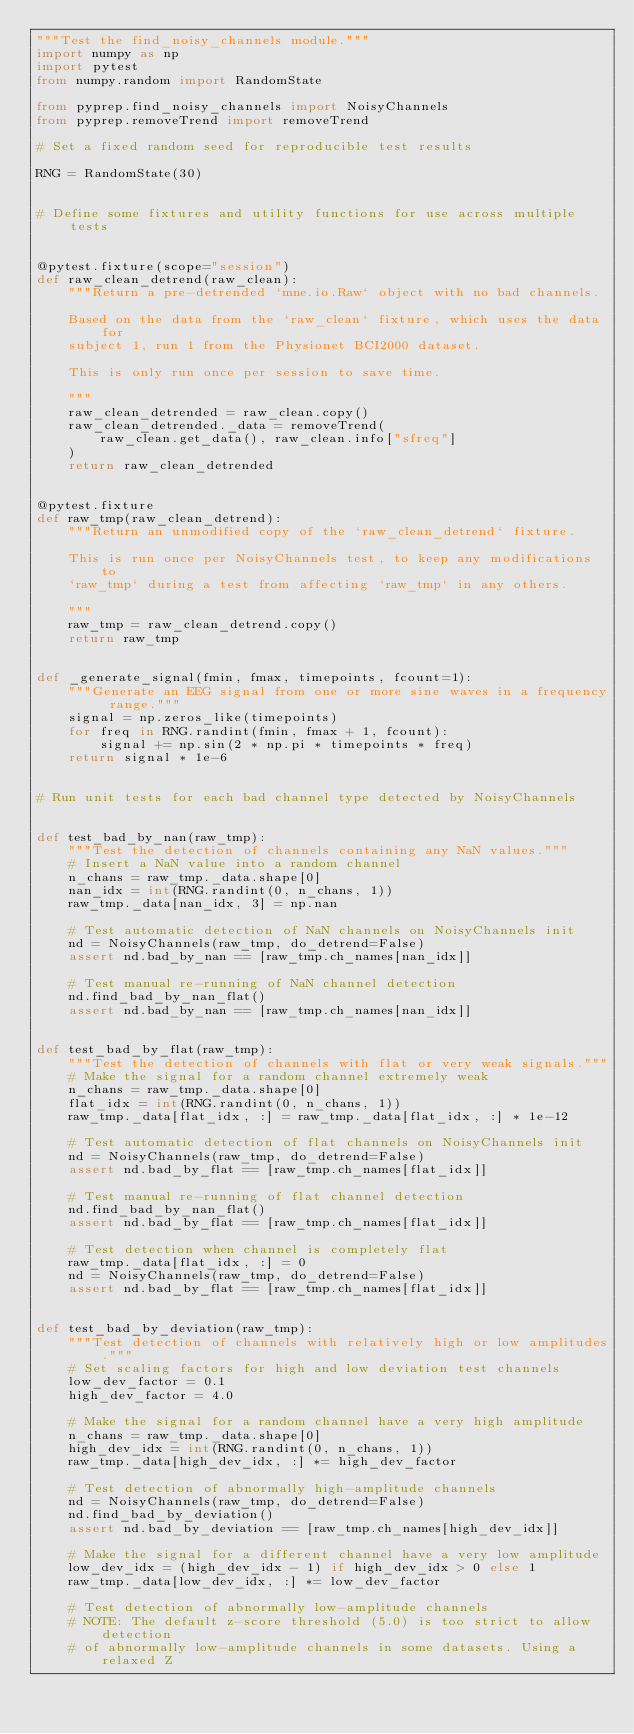Convert code to text. <code><loc_0><loc_0><loc_500><loc_500><_Python_>"""Test the find_noisy_channels module."""
import numpy as np
import pytest
from numpy.random import RandomState

from pyprep.find_noisy_channels import NoisyChannels
from pyprep.removeTrend import removeTrend

# Set a fixed random seed for reproducible test results

RNG = RandomState(30)


# Define some fixtures and utility functions for use across multiple tests


@pytest.fixture(scope="session")
def raw_clean_detrend(raw_clean):
    """Return a pre-detrended `mne.io.Raw` object with no bad channels.

    Based on the data from the `raw_clean` fixture, which uses the data for
    subject 1, run 1 from the Physionet BCI2000 dataset.

    This is only run once per session to save time.

    """
    raw_clean_detrended = raw_clean.copy()
    raw_clean_detrended._data = removeTrend(
        raw_clean.get_data(), raw_clean.info["sfreq"]
    )
    return raw_clean_detrended


@pytest.fixture
def raw_tmp(raw_clean_detrend):
    """Return an unmodified copy of the `raw_clean_detrend` fixture.

    This is run once per NoisyChannels test, to keep any modifications to
    `raw_tmp` during a test from affecting `raw_tmp` in any others.

    """
    raw_tmp = raw_clean_detrend.copy()
    return raw_tmp


def _generate_signal(fmin, fmax, timepoints, fcount=1):
    """Generate an EEG signal from one or more sine waves in a frequency range."""
    signal = np.zeros_like(timepoints)
    for freq in RNG.randint(fmin, fmax + 1, fcount):
        signal += np.sin(2 * np.pi * timepoints * freq)
    return signal * 1e-6


# Run unit tests for each bad channel type detected by NoisyChannels


def test_bad_by_nan(raw_tmp):
    """Test the detection of channels containing any NaN values."""
    # Insert a NaN value into a random channel
    n_chans = raw_tmp._data.shape[0]
    nan_idx = int(RNG.randint(0, n_chans, 1))
    raw_tmp._data[nan_idx, 3] = np.nan

    # Test automatic detection of NaN channels on NoisyChannels init
    nd = NoisyChannels(raw_tmp, do_detrend=False)
    assert nd.bad_by_nan == [raw_tmp.ch_names[nan_idx]]

    # Test manual re-running of NaN channel detection
    nd.find_bad_by_nan_flat()
    assert nd.bad_by_nan == [raw_tmp.ch_names[nan_idx]]


def test_bad_by_flat(raw_tmp):
    """Test the detection of channels with flat or very weak signals."""
    # Make the signal for a random channel extremely weak
    n_chans = raw_tmp._data.shape[0]
    flat_idx = int(RNG.randint(0, n_chans, 1))
    raw_tmp._data[flat_idx, :] = raw_tmp._data[flat_idx, :] * 1e-12

    # Test automatic detection of flat channels on NoisyChannels init
    nd = NoisyChannels(raw_tmp, do_detrend=False)
    assert nd.bad_by_flat == [raw_tmp.ch_names[flat_idx]]

    # Test manual re-running of flat channel detection
    nd.find_bad_by_nan_flat()
    assert nd.bad_by_flat == [raw_tmp.ch_names[flat_idx]]

    # Test detection when channel is completely flat
    raw_tmp._data[flat_idx, :] = 0
    nd = NoisyChannels(raw_tmp, do_detrend=False)
    assert nd.bad_by_flat == [raw_tmp.ch_names[flat_idx]]


def test_bad_by_deviation(raw_tmp):
    """Test detection of channels with relatively high or low amplitudes."""
    # Set scaling factors for high and low deviation test channels
    low_dev_factor = 0.1
    high_dev_factor = 4.0

    # Make the signal for a random channel have a very high amplitude
    n_chans = raw_tmp._data.shape[0]
    high_dev_idx = int(RNG.randint(0, n_chans, 1))
    raw_tmp._data[high_dev_idx, :] *= high_dev_factor

    # Test detection of abnormally high-amplitude channels
    nd = NoisyChannels(raw_tmp, do_detrend=False)
    nd.find_bad_by_deviation()
    assert nd.bad_by_deviation == [raw_tmp.ch_names[high_dev_idx]]

    # Make the signal for a different channel have a very low amplitude
    low_dev_idx = (high_dev_idx - 1) if high_dev_idx > 0 else 1
    raw_tmp._data[low_dev_idx, :] *= low_dev_factor

    # Test detection of abnormally low-amplitude channels
    # NOTE: The default z-score threshold (5.0) is too strict to allow detection
    # of abnormally low-amplitude channels in some datasets. Using a relaxed Z</code> 